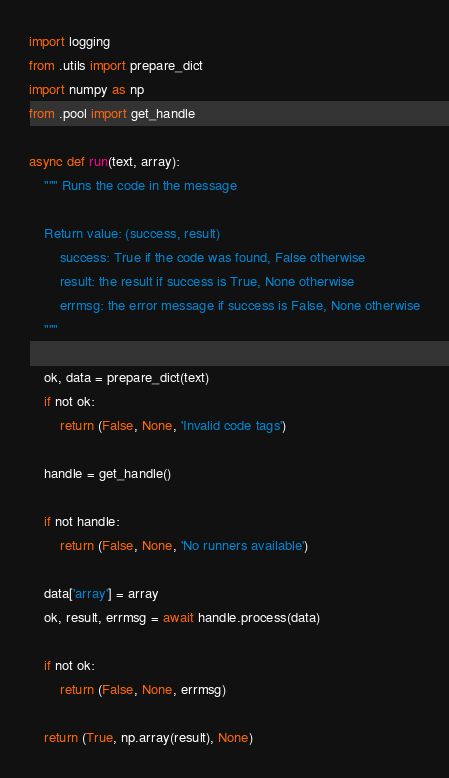<code> <loc_0><loc_0><loc_500><loc_500><_Python_>import logging
from .utils import prepare_dict
import numpy as np
from .pool import get_handle

async def run(text, array):
    """ Runs the code in the message
    
    Return value: (success, result)
        success: True if the code was found, False otherwise
        result: the result if success is True, None otherwise
        errmsg: the error message if success is False, None otherwise
    """

    ok, data = prepare_dict(text)
    if not ok:
        return (False, None, 'Invalid code tags')

    handle = get_handle()

    if not handle:
        return (False, None, 'No runners available')

    data['array'] = array
    ok, result, errmsg = await handle.process(data)

    if not ok:
        return (False, None, errmsg)

    return (True, np.array(result), None)
</code> 